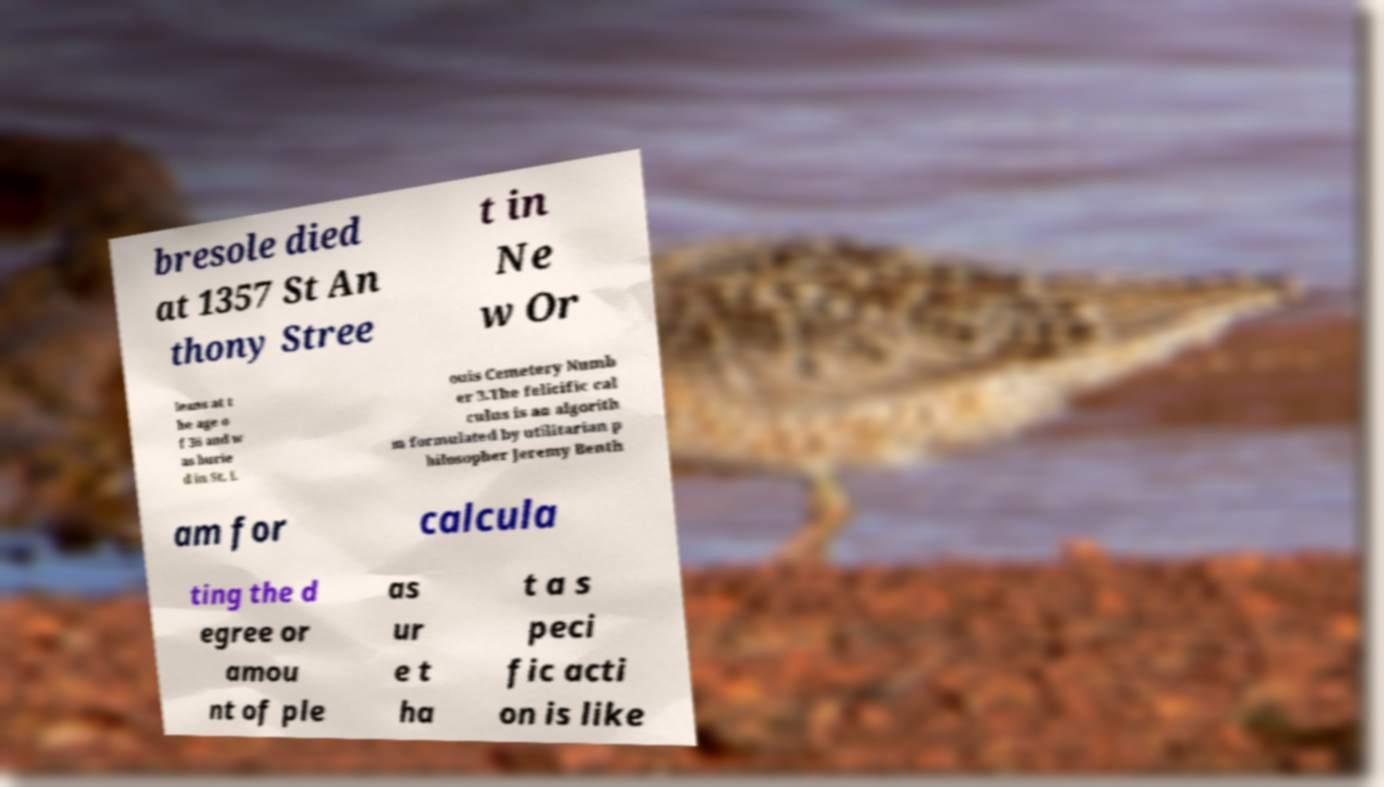Please read and relay the text visible in this image. What does it say? bresole died at 1357 St An thony Stree t in Ne w Or leans at t he age o f 36 and w as burie d in St. L ouis Cemetery Numb er 3.The felicific cal culus is an algorith m formulated by utilitarian p hilosopher Jeremy Benth am for calcula ting the d egree or amou nt of ple as ur e t ha t a s peci fic acti on is like 